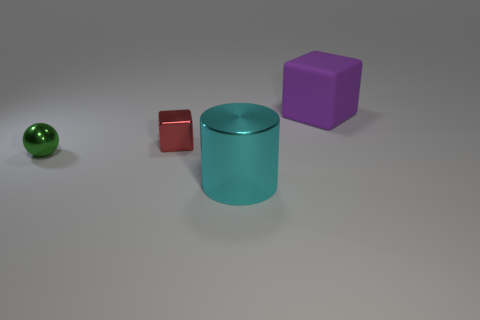Add 4 red cubes. How many objects exist? 8 Subtract all purple cubes. How many cubes are left? 1 Subtract all cylinders. How many objects are left? 3 Subtract 0 gray cylinders. How many objects are left? 4 Subtract 1 cylinders. How many cylinders are left? 0 Subtract all blue cylinders. Subtract all green blocks. How many cylinders are left? 1 Subtract all small green rubber cylinders. Subtract all green objects. How many objects are left? 3 Add 4 tiny red metallic objects. How many tiny red metallic objects are left? 5 Add 4 large yellow shiny blocks. How many large yellow shiny blocks exist? 4 